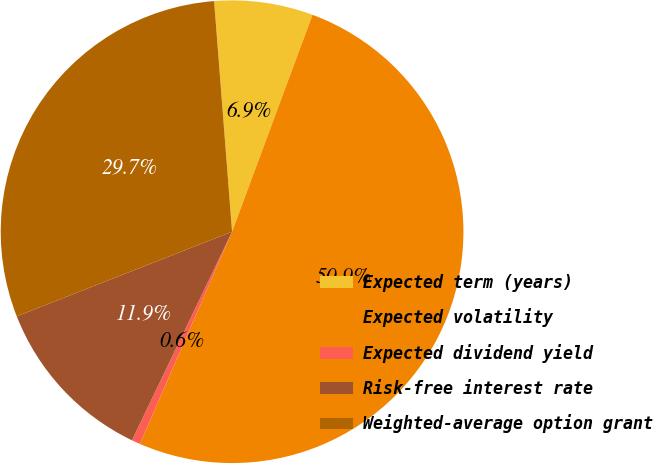Convert chart to OTSL. <chart><loc_0><loc_0><loc_500><loc_500><pie_chart><fcel>Expected term (years)<fcel>Expected volatility<fcel>Expected dividend yield<fcel>Risk-free interest rate<fcel>Weighted-average option grant<nl><fcel>6.89%<fcel>50.87%<fcel>0.6%<fcel>11.92%<fcel>29.72%<nl></chart> 